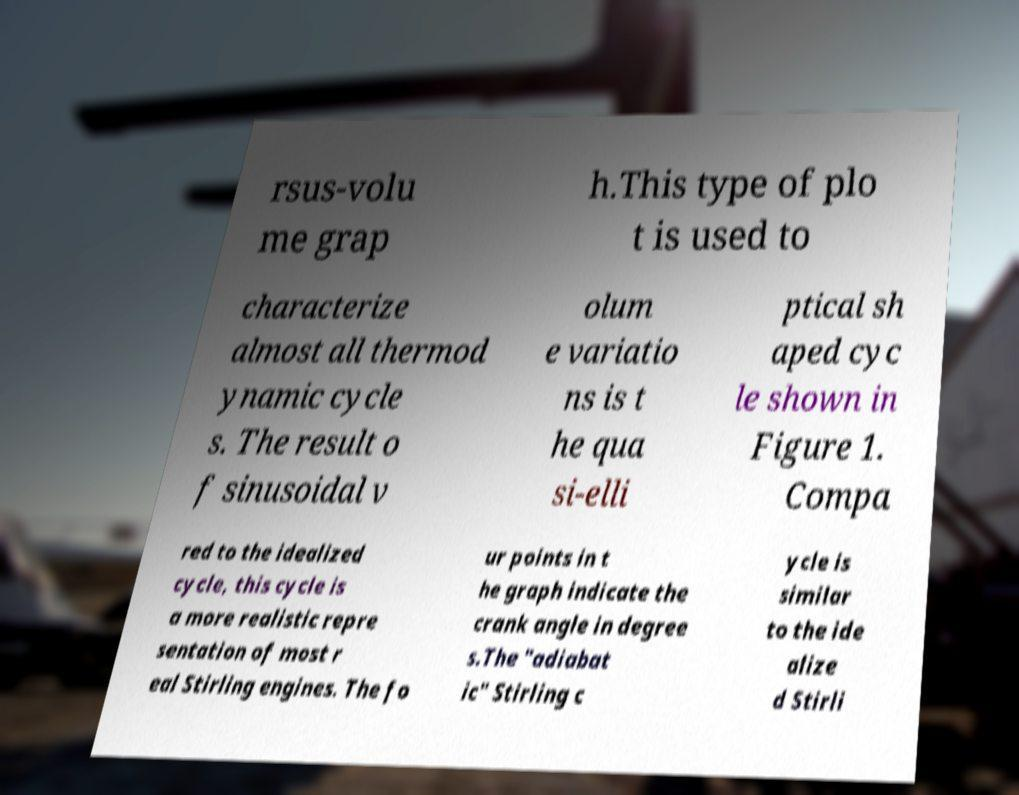Could you assist in decoding the text presented in this image and type it out clearly? rsus-volu me grap h.This type of plo t is used to characterize almost all thermod ynamic cycle s. The result o f sinusoidal v olum e variatio ns is t he qua si-elli ptical sh aped cyc le shown in Figure 1. Compa red to the idealized cycle, this cycle is a more realistic repre sentation of most r eal Stirling engines. The fo ur points in t he graph indicate the crank angle in degree s.The "adiabat ic" Stirling c ycle is similar to the ide alize d Stirli 